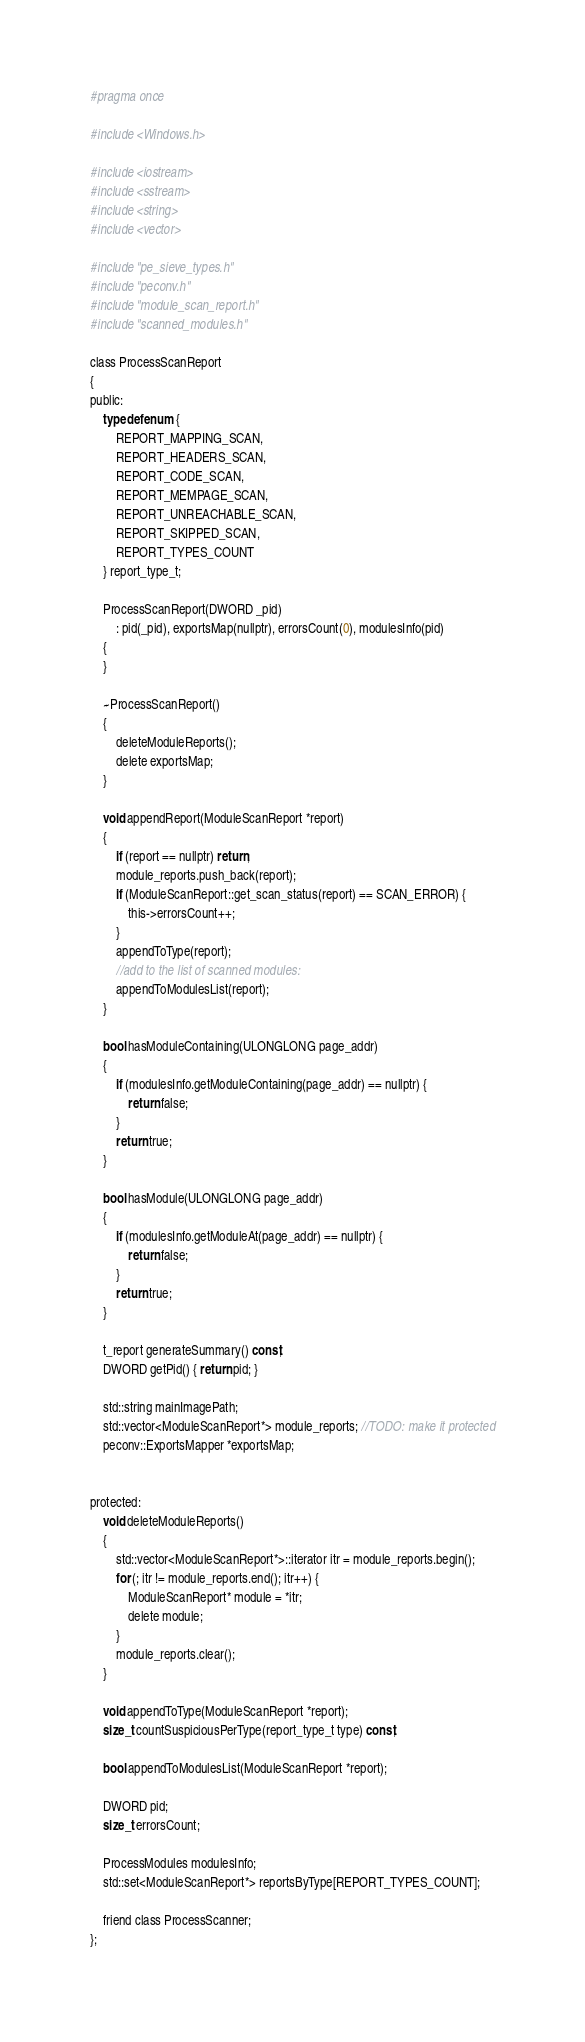Convert code to text. <code><loc_0><loc_0><loc_500><loc_500><_C_>#pragma once

#include <Windows.h>

#include <iostream>
#include <sstream>
#include <string>
#include <vector>

#include "pe_sieve_types.h"
#include "peconv.h"
#include "module_scan_report.h"
#include "scanned_modules.h"

class ProcessScanReport
{
public:
	typedef enum {
		REPORT_MAPPING_SCAN,
		REPORT_HEADERS_SCAN,
		REPORT_CODE_SCAN,
		REPORT_MEMPAGE_SCAN,
		REPORT_UNREACHABLE_SCAN,
		REPORT_SKIPPED_SCAN,
		REPORT_TYPES_COUNT
	} report_type_t;

	ProcessScanReport(DWORD _pid)
		: pid(_pid), exportsMap(nullptr), errorsCount(0), modulesInfo(pid)
	{
	}

	~ProcessScanReport()
	{
		deleteModuleReports();
		delete exportsMap;
	}

	void appendReport(ModuleScanReport *report)
	{
		if (report == nullptr) return;
		module_reports.push_back(report);
		if (ModuleScanReport::get_scan_status(report) == SCAN_ERROR) {
			this->errorsCount++;
		}
		appendToType(report);
		//add to the list of scanned modules:
		appendToModulesList(report);
	}

	bool hasModuleContaining(ULONGLONG page_addr)
	{
		if (modulesInfo.getModuleContaining(page_addr) == nullptr) {
			return false;
		}
		return true;
	}

	bool hasModule(ULONGLONG page_addr)
	{
		if (modulesInfo.getModuleAt(page_addr) == nullptr) {
			return false;
		}
		return true;
	}

	t_report generateSummary() const;
	DWORD getPid() { return pid; }

	std::string mainImagePath;
	std::vector<ModuleScanReport*> module_reports; //TODO: make it protected
	peconv::ExportsMapper *exportsMap;


protected:
	void deleteModuleReports()
	{
		std::vector<ModuleScanReport*>::iterator itr = module_reports.begin();
		for (; itr != module_reports.end(); itr++) {
			ModuleScanReport* module = *itr;
			delete module;
		}
		module_reports.clear();
	}

	void appendToType(ModuleScanReport *report);
	size_t countSuspiciousPerType(report_type_t type) const;

	bool appendToModulesList(ModuleScanReport *report);

	DWORD pid;
	size_t errorsCount;

	ProcessModules modulesInfo;
	std::set<ModuleScanReport*> reportsByType[REPORT_TYPES_COUNT];

	friend class ProcessScanner;
};
</code> 